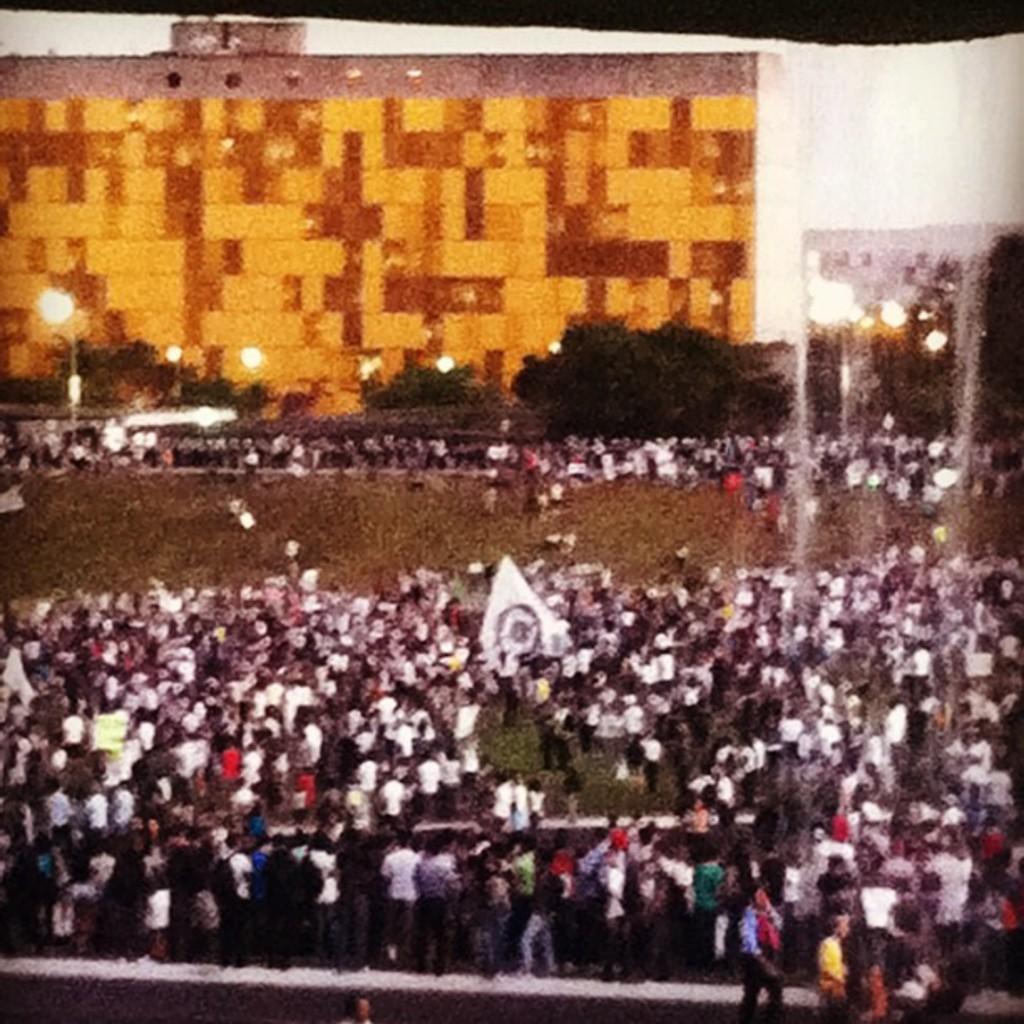Could you give a brief overview of what you see in this image? In this image there is a ground. There is a huge crowd of people. There is grass. There are trees. There are buildings in the background. There are street lights. There is a sky. 